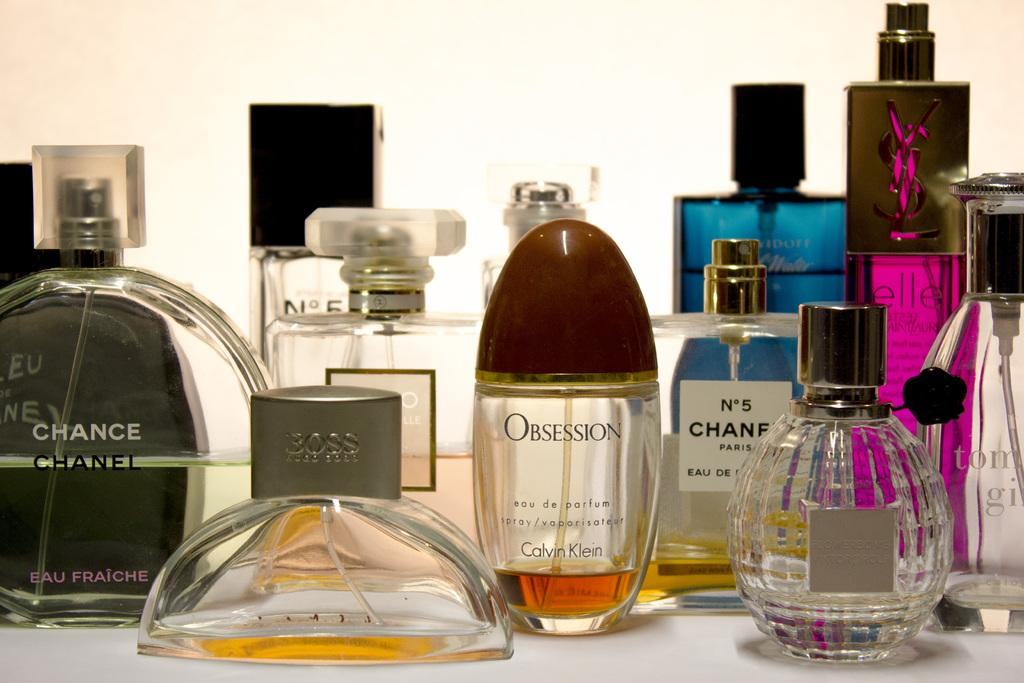<image>
Provide a brief description of the given image. The perfume bottles include Obsession, No 5 Chanel, and Elle. 